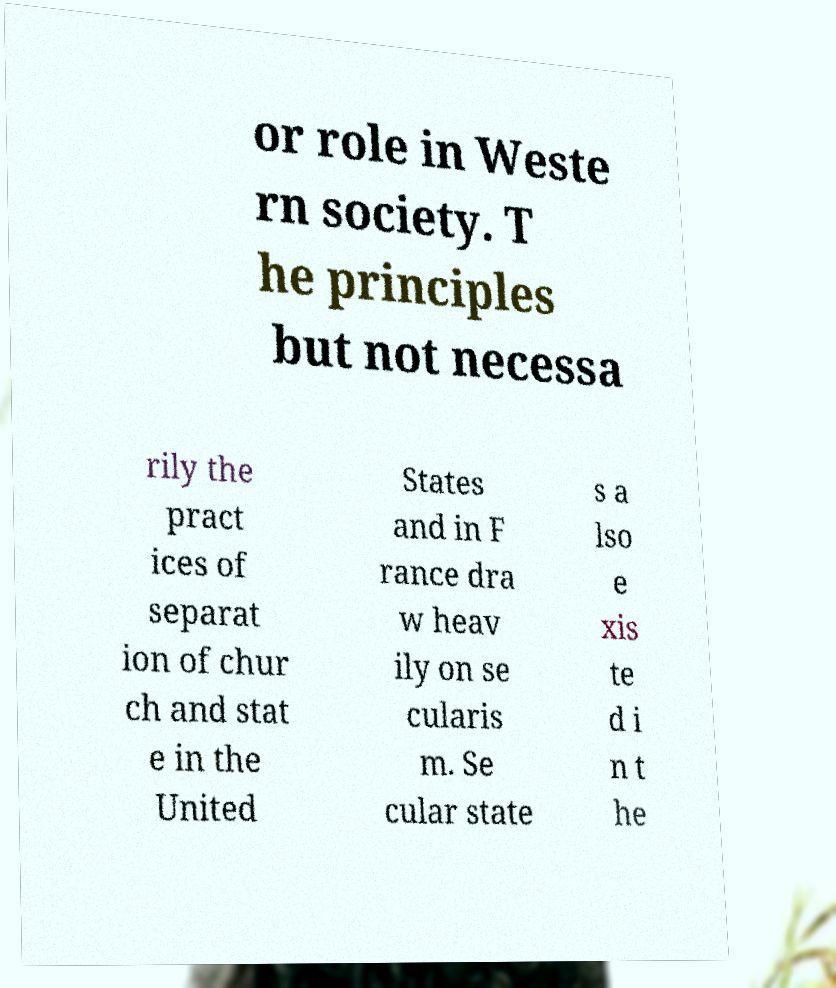For documentation purposes, I need the text within this image transcribed. Could you provide that? or role in Weste rn society. T he principles but not necessa rily the pract ices of separat ion of chur ch and stat e in the United States and in F rance dra w heav ily on se cularis m. Se cular state s a lso e xis te d i n t he 